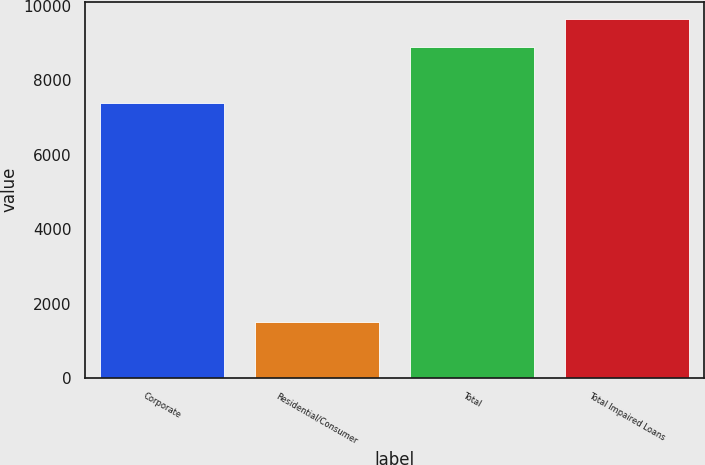Convert chart. <chart><loc_0><loc_0><loc_500><loc_500><bar_chart><fcel>Corporate<fcel>Residential/Consumer<fcel>Total<fcel>Total Impaired Loans<nl><fcel>7383<fcel>1507<fcel>8890<fcel>9628.3<nl></chart> 